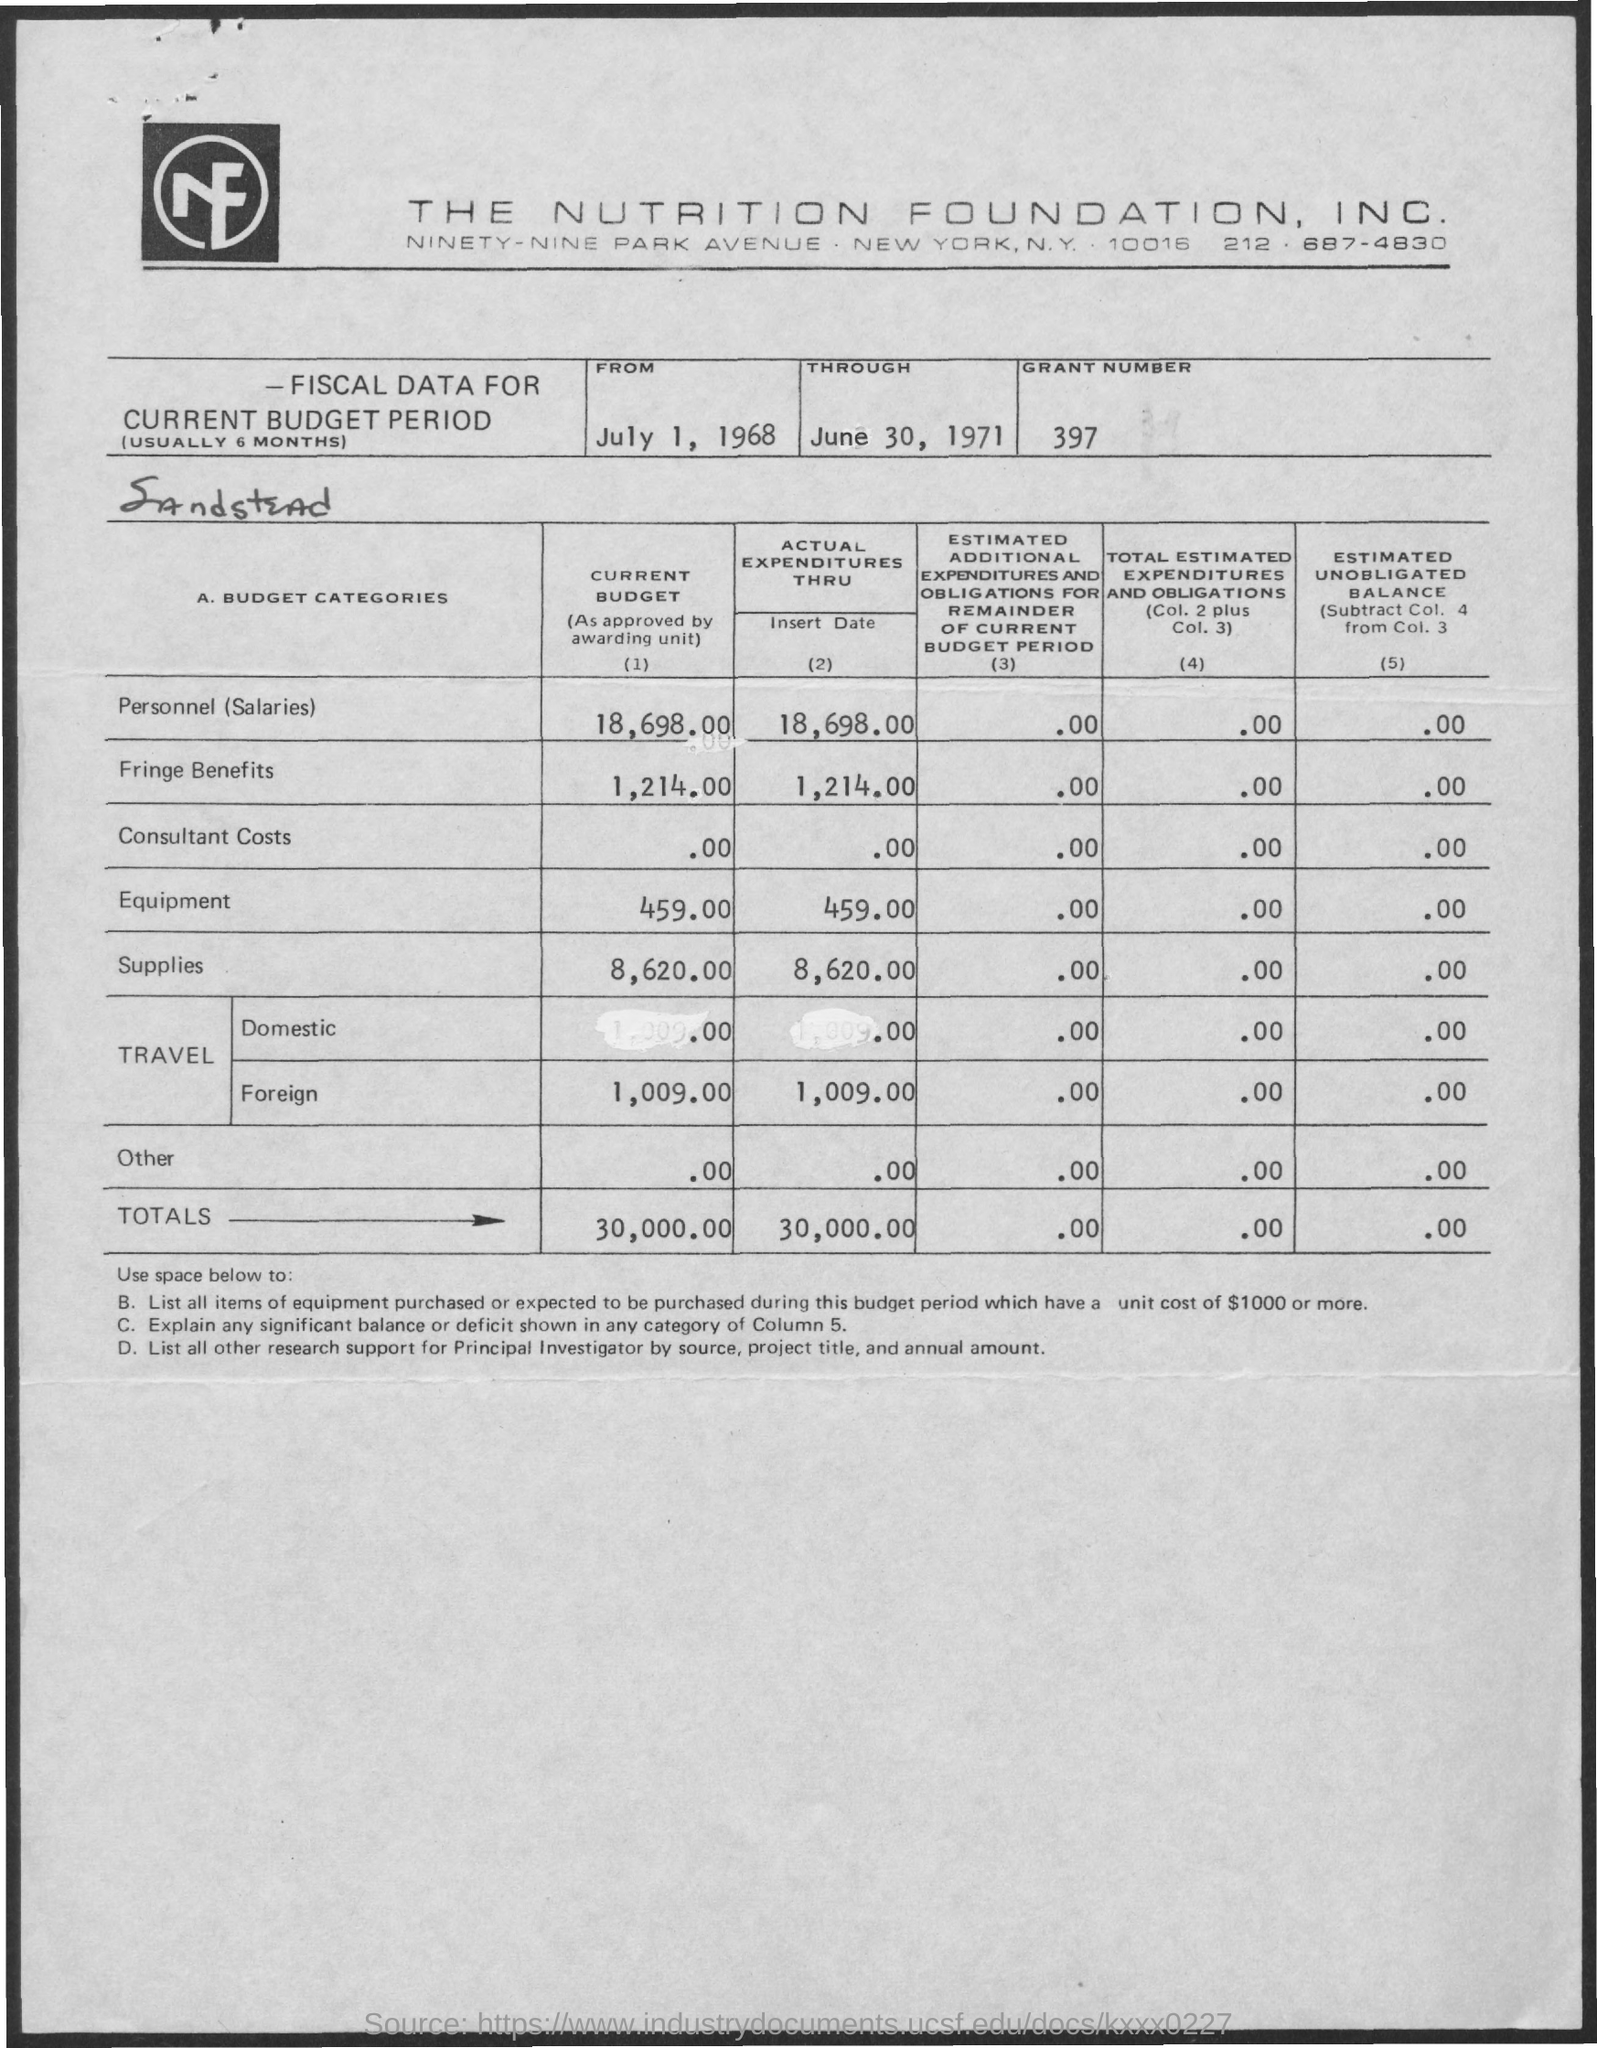What is the amount of personnel (salaries) in the current budget ?
Keep it short and to the point. 18,698.00. What is the amount of fringe benefits in the current budget ?
Provide a succinct answer. 1,214.00. What is the amount of equipment in the current budget ?
Your response must be concise. 459.00. What is the amount of supplies in the current budget ?
Offer a terse response. 8,620.00. What is the amount of foreign travel in the actual expenditures ?
Offer a terse response. 1,009.00. What is the total amount shown in the current budget ?
Provide a short and direct response. 30,000.00. What is the total amount shown in the actual expenditures ?
Offer a very short reply. 30,000.00. What is the grant number mentioned in the given page ?
Provide a short and direct response. 397. 